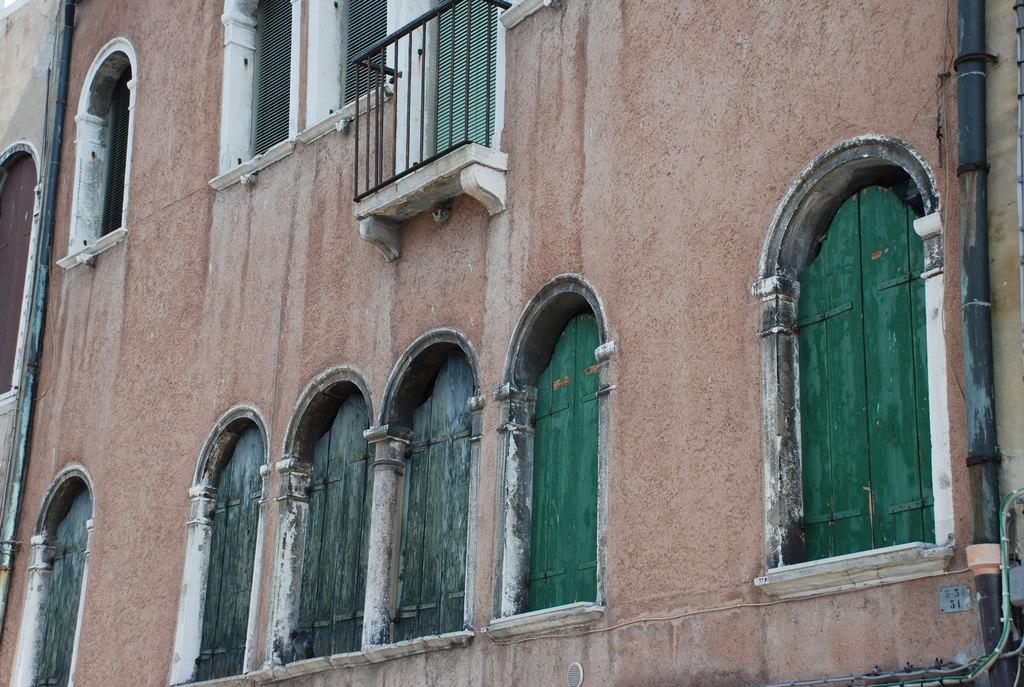What is the main subject of the image? The main subject of the image is a building. Can you describe the windows in the image? There are windows visible at the bottom and top of the image. What type of disease is affecting the creature in the image? There is no creature or disease present in the image; it is a zoomed-in view of a building with windows. Is the queen visible in the image? There is no queen present in the image; it is a zoomed-in view of a building with windows. 